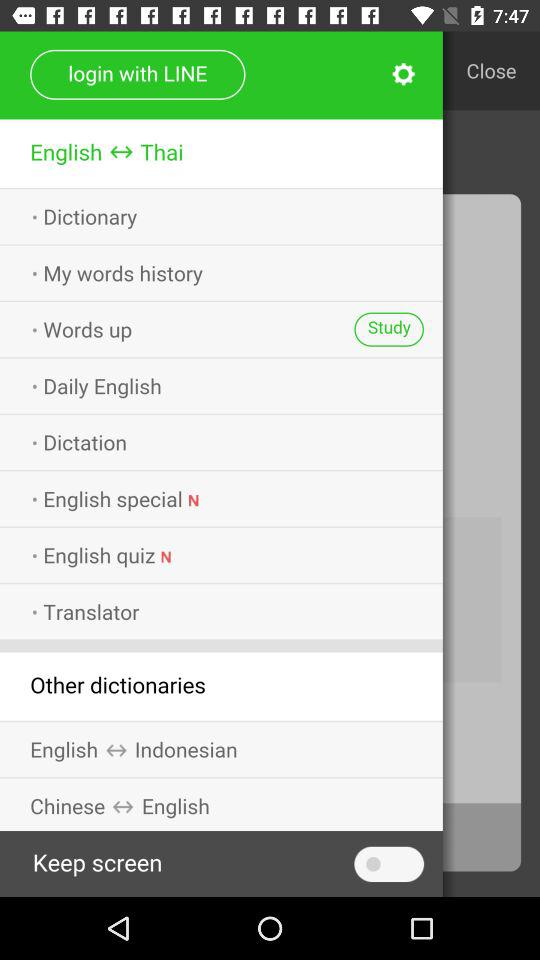Which languages can other dictionaries translate between? Other dictionaries can translate between English and Indonesian; Chinese and English. 